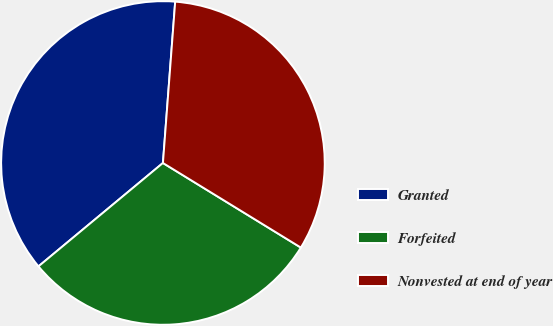<chart> <loc_0><loc_0><loc_500><loc_500><pie_chart><fcel>Granted<fcel>Forfeited<fcel>Nonvested at end of year<nl><fcel>37.24%<fcel>30.21%<fcel>32.55%<nl></chart> 